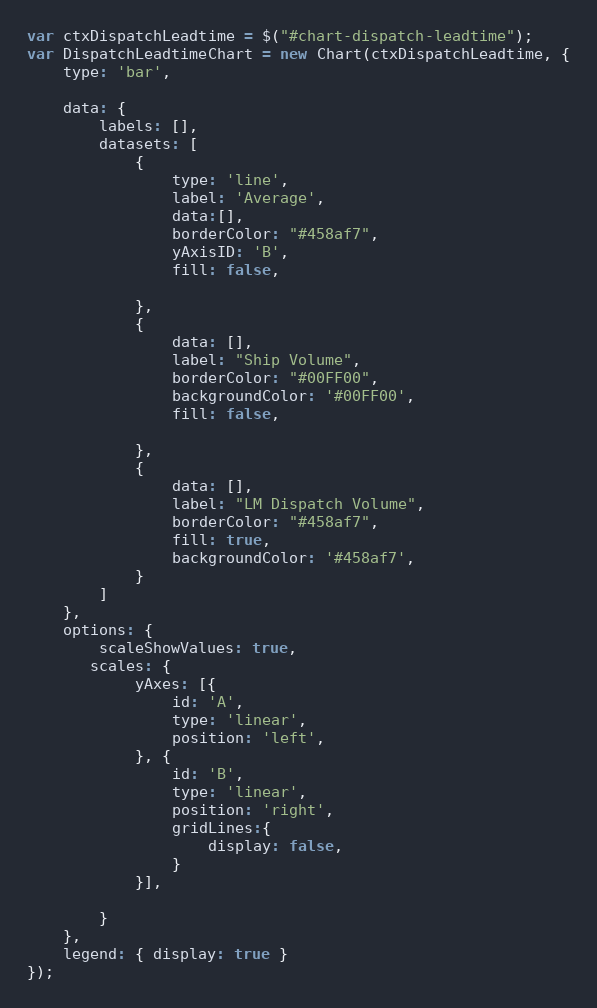<code> <loc_0><loc_0><loc_500><loc_500><_JavaScript_>var ctxDispatchLeadtime = $("#chart-dispatch-leadtime");
var DispatchLeadtimeChart = new Chart(ctxDispatchLeadtime, {
    type: 'bar',
    
    data: {
        labels: [],
        datasets: [
            {
                type: 'line',
                label: 'Average',
                data:[],
                borderColor: "#458af7",
                yAxisID: 'B',
                fill: false,

            },
            {
                data: [],
                label: "Ship Volume",
                borderColor: "#00FF00",
                backgroundColor: '#00FF00',
                fill: false,
               
            }, 
            {
                data: [],
                label: "LM Dispatch Volume",
                borderColor: "#458af7",
                fill: true,
                backgroundColor: '#458af7',
            }
        ]
    },
    options: {
        scaleShowValues: true,
       scales: {
            yAxes: [{
                id: 'A',
                type: 'linear',
                position: 'left',
            }, {
                id: 'B',
                type: 'linear',
                position: 'right',
                gridLines:{
                    display: false,
                }
            }],
            
        }
    },
    legend: { display: true }
});

</code> 